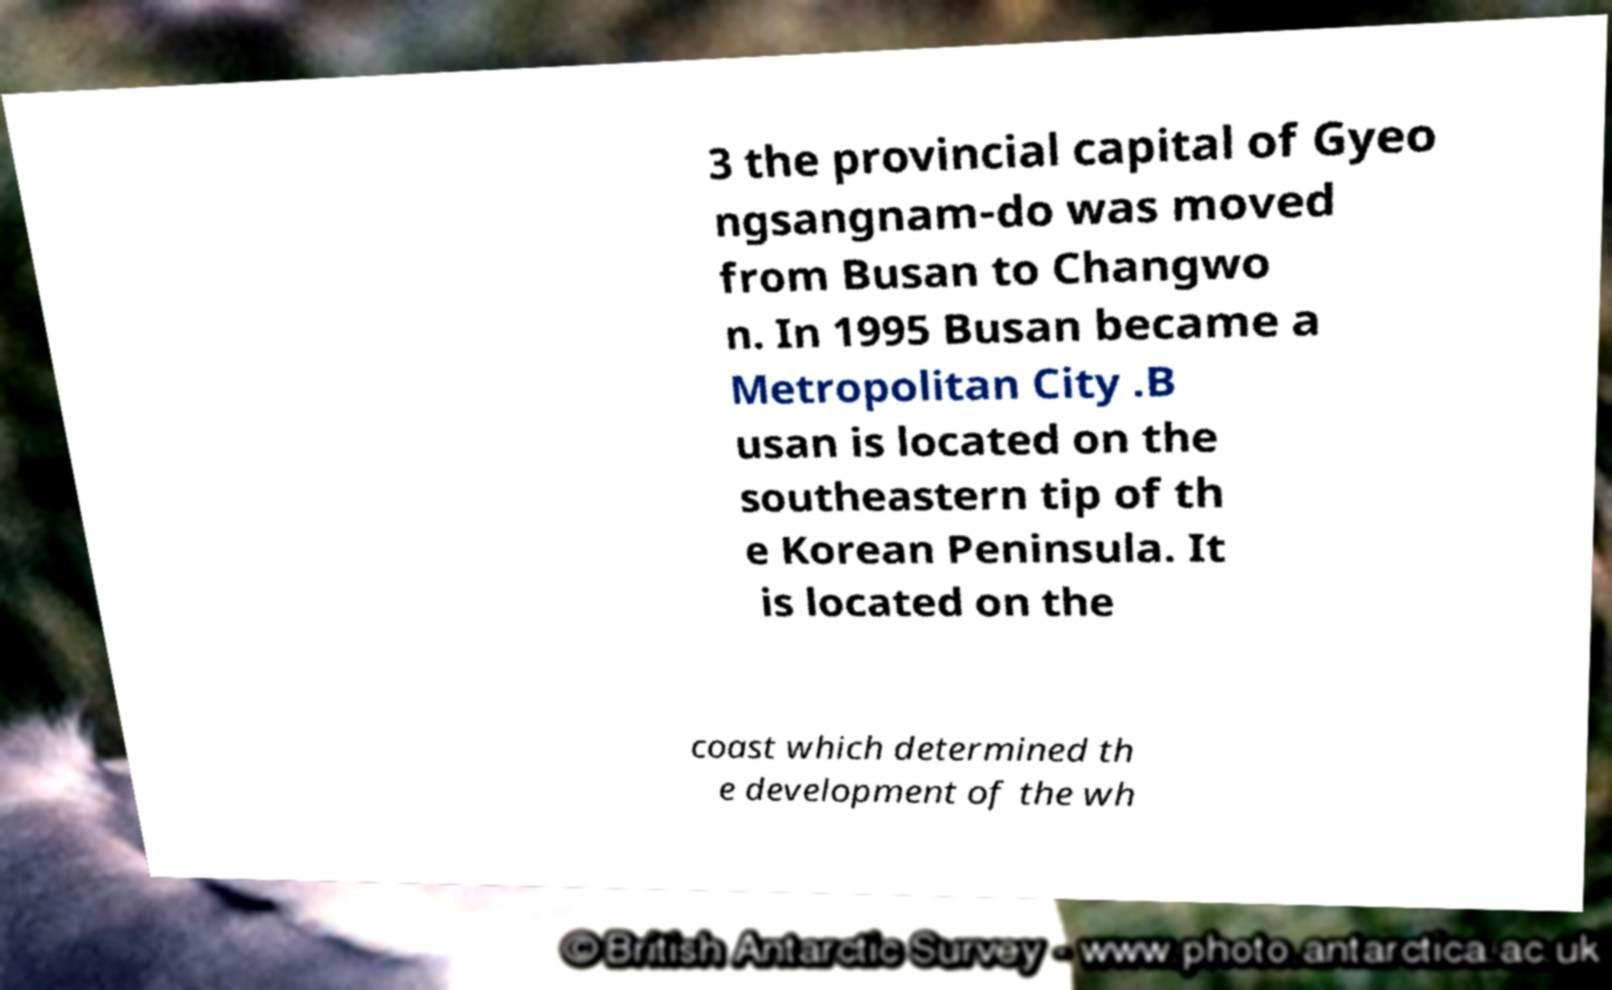Could you assist in decoding the text presented in this image and type it out clearly? 3 the provincial capital of Gyeo ngsangnam-do was moved from Busan to Changwo n. In 1995 Busan became a Metropolitan City .B usan is located on the southeastern tip of th e Korean Peninsula. It is located on the coast which determined th e development of the wh 